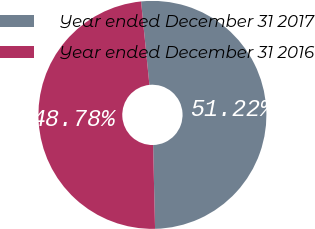<chart> <loc_0><loc_0><loc_500><loc_500><pie_chart><fcel>Year ended December 31 2017<fcel>Year ended December 31 2016<nl><fcel>51.22%<fcel>48.78%<nl></chart> 